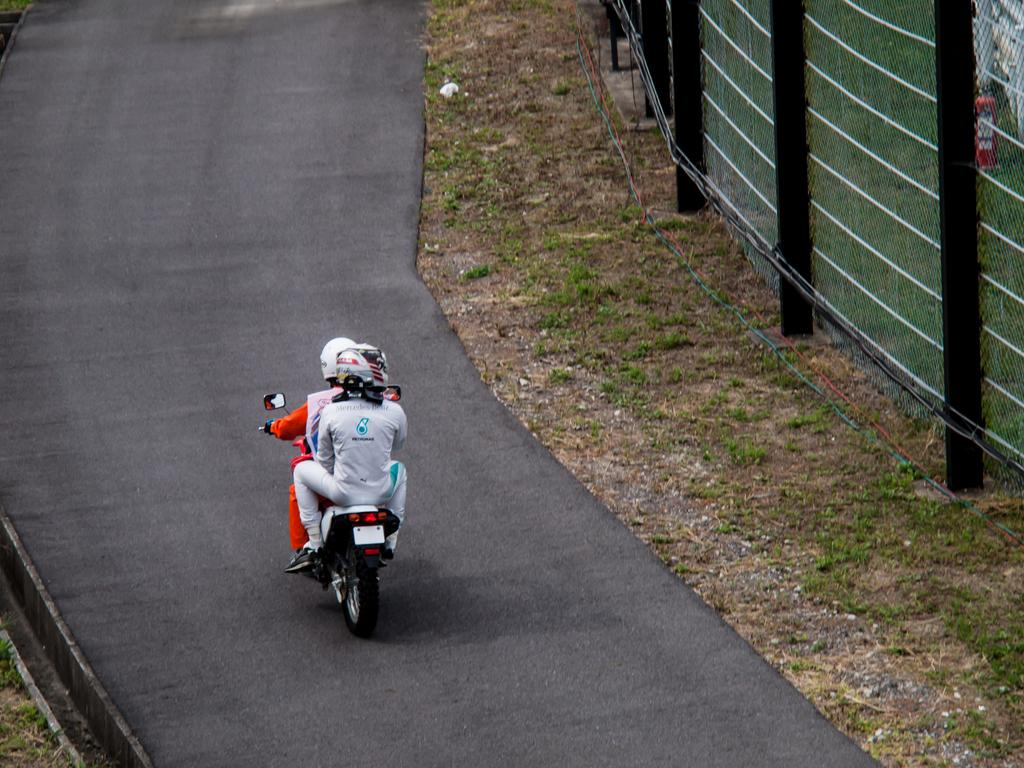How many people are in the image? There are two persons in the image. What are the persons doing in the image? The persons are sitting on a bike. What safety precautions are the persons taking in the image? The persons are wearing helmets. What can be seen in the background of the image? There is a road in the image. What is on the right side of the image? There is a fencing on the right side of the image. What type of cushion can be seen on the sidewalk in the image? There is no cushion or sidewalk present in the image. Is there a squirrel visible on the bike with the persons in the image? There is no squirrel present in the image; only the two persons and the bike are visible. 